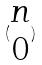<formula> <loc_0><loc_0><loc_500><loc_500>( \begin{matrix} n \\ 0 \end{matrix} )</formula> 